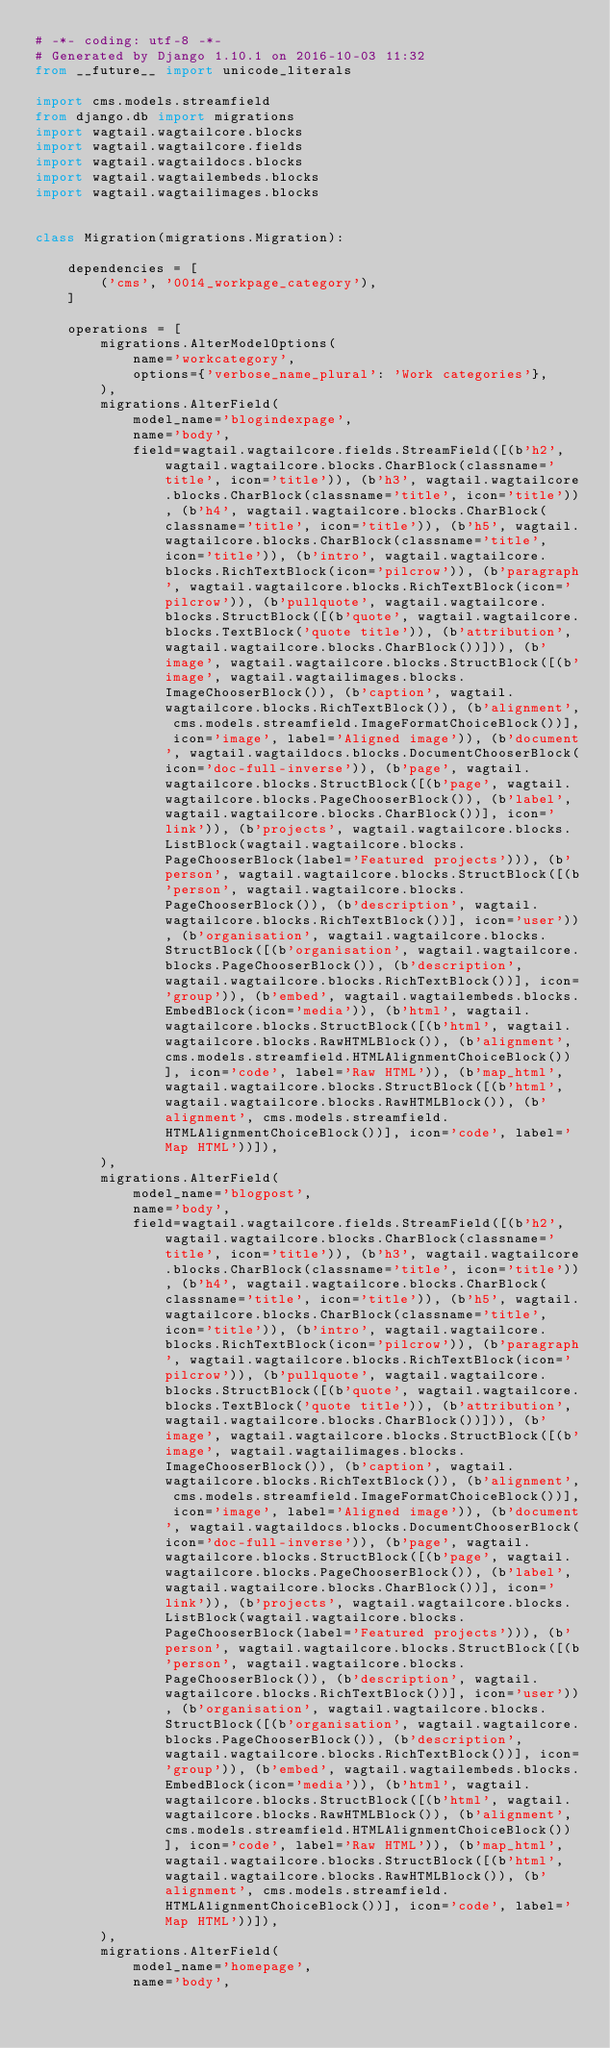Convert code to text. <code><loc_0><loc_0><loc_500><loc_500><_Python_># -*- coding: utf-8 -*-
# Generated by Django 1.10.1 on 2016-10-03 11:32
from __future__ import unicode_literals

import cms.models.streamfield
from django.db import migrations
import wagtail.wagtailcore.blocks
import wagtail.wagtailcore.fields
import wagtail.wagtaildocs.blocks
import wagtail.wagtailembeds.blocks
import wagtail.wagtailimages.blocks


class Migration(migrations.Migration):

    dependencies = [
        ('cms', '0014_workpage_category'),
    ]

    operations = [
        migrations.AlterModelOptions(
            name='workcategory',
            options={'verbose_name_plural': 'Work categories'},
        ),
        migrations.AlterField(
            model_name='blogindexpage',
            name='body',
            field=wagtail.wagtailcore.fields.StreamField([(b'h2', wagtail.wagtailcore.blocks.CharBlock(classname='title', icon='title')), (b'h3', wagtail.wagtailcore.blocks.CharBlock(classname='title', icon='title')), (b'h4', wagtail.wagtailcore.blocks.CharBlock(classname='title', icon='title')), (b'h5', wagtail.wagtailcore.blocks.CharBlock(classname='title', icon='title')), (b'intro', wagtail.wagtailcore.blocks.RichTextBlock(icon='pilcrow')), (b'paragraph', wagtail.wagtailcore.blocks.RichTextBlock(icon='pilcrow')), (b'pullquote', wagtail.wagtailcore.blocks.StructBlock([(b'quote', wagtail.wagtailcore.blocks.TextBlock('quote title')), (b'attribution', wagtail.wagtailcore.blocks.CharBlock())])), (b'image', wagtail.wagtailcore.blocks.StructBlock([(b'image', wagtail.wagtailimages.blocks.ImageChooserBlock()), (b'caption', wagtail.wagtailcore.blocks.RichTextBlock()), (b'alignment', cms.models.streamfield.ImageFormatChoiceBlock())], icon='image', label='Aligned image')), (b'document', wagtail.wagtaildocs.blocks.DocumentChooserBlock(icon='doc-full-inverse')), (b'page', wagtail.wagtailcore.blocks.StructBlock([(b'page', wagtail.wagtailcore.blocks.PageChooserBlock()), (b'label', wagtail.wagtailcore.blocks.CharBlock())], icon='link')), (b'projects', wagtail.wagtailcore.blocks.ListBlock(wagtail.wagtailcore.blocks.PageChooserBlock(label='Featured projects'))), (b'person', wagtail.wagtailcore.blocks.StructBlock([(b'person', wagtail.wagtailcore.blocks.PageChooserBlock()), (b'description', wagtail.wagtailcore.blocks.RichTextBlock())], icon='user')), (b'organisation', wagtail.wagtailcore.blocks.StructBlock([(b'organisation', wagtail.wagtailcore.blocks.PageChooserBlock()), (b'description', wagtail.wagtailcore.blocks.RichTextBlock())], icon='group')), (b'embed', wagtail.wagtailembeds.blocks.EmbedBlock(icon='media')), (b'html', wagtail.wagtailcore.blocks.StructBlock([(b'html', wagtail.wagtailcore.blocks.RawHTMLBlock()), (b'alignment', cms.models.streamfield.HTMLAlignmentChoiceBlock())], icon='code', label='Raw HTML')), (b'map_html', wagtail.wagtailcore.blocks.StructBlock([(b'html', wagtail.wagtailcore.blocks.RawHTMLBlock()), (b'alignment', cms.models.streamfield.HTMLAlignmentChoiceBlock())], icon='code', label='Map HTML'))]),
        ),
        migrations.AlterField(
            model_name='blogpost',
            name='body',
            field=wagtail.wagtailcore.fields.StreamField([(b'h2', wagtail.wagtailcore.blocks.CharBlock(classname='title', icon='title')), (b'h3', wagtail.wagtailcore.blocks.CharBlock(classname='title', icon='title')), (b'h4', wagtail.wagtailcore.blocks.CharBlock(classname='title', icon='title')), (b'h5', wagtail.wagtailcore.blocks.CharBlock(classname='title', icon='title')), (b'intro', wagtail.wagtailcore.blocks.RichTextBlock(icon='pilcrow')), (b'paragraph', wagtail.wagtailcore.blocks.RichTextBlock(icon='pilcrow')), (b'pullquote', wagtail.wagtailcore.blocks.StructBlock([(b'quote', wagtail.wagtailcore.blocks.TextBlock('quote title')), (b'attribution', wagtail.wagtailcore.blocks.CharBlock())])), (b'image', wagtail.wagtailcore.blocks.StructBlock([(b'image', wagtail.wagtailimages.blocks.ImageChooserBlock()), (b'caption', wagtail.wagtailcore.blocks.RichTextBlock()), (b'alignment', cms.models.streamfield.ImageFormatChoiceBlock())], icon='image', label='Aligned image')), (b'document', wagtail.wagtaildocs.blocks.DocumentChooserBlock(icon='doc-full-inverse')), (b'page', wagtail.wagtailcore.blocks.StructBlock([(b'page', wagtail.wagtailcore.blocks.PageChooserBlock()), (b'label', wagtail.wagtailcore.blocks.CharBlock())], icon='link')), (b'projects', wagtail.wagtailcore.blocks.ListBlock(wagtail.wagtailcore.blocks.PageChooserBlock(label='Featured projects'))), (b'person', wagtail.wagtailcore.blocks.StructBlock([(b'person', wagtail.wagtailcore.blocks.PageChooserBlock()), (b'description', wagtail.wagtailcore.blocks.RichTextBlock())], icon='user')), (b'organisation', wagtail.wagtailcore.blocks.StructBlock([(b'organisation', wagtail.wagtailcore.blocks.PageChooserBlock()), (b'description', wagtail.wagtailcore.blocks.RichTextBlock())], icon='group')), (b'embed', wagtail.wagtailembeds.blocks.EmbedBlock(icon='media')), (b'html', wagtail.wagtailcore.blocks.StructBlock([(b'html', wagtail.wagtailcore.blocks.RawHTMLBlock()), (b'alignment', cms.models.streamfield.HTMLAlignmentChoiceBlock())], icon='code', label='Raw HTML')), (b'map_html', wagtail.wagtailcore.blocks.StructBlock([(b'html', wagtail.wagtailcore.blocks.RawHTMLBlock()), (b'alignment', cms.models.streamfield.HTMLAlignmentChoiceBlock())], icon='code', label='Map HTML'))]),
        ),
        migrations.AlterField(
            model_name='homepage',
            name='body',</code> 